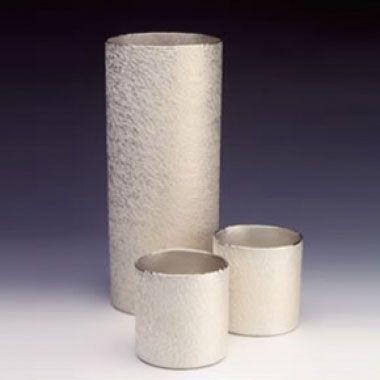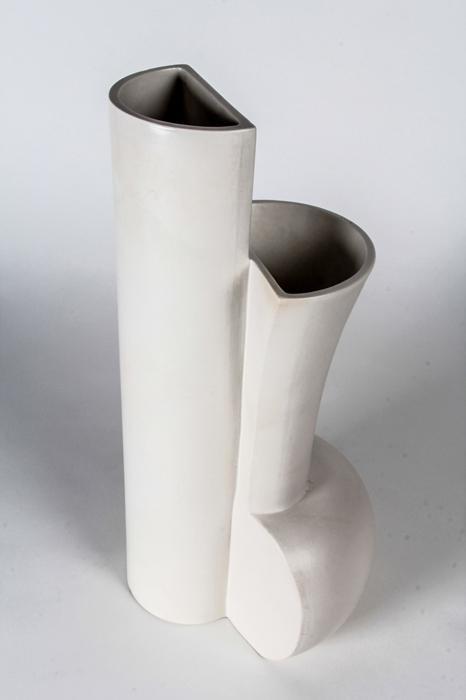The first image is the image on the left, the second image is the image on the right. Examine the images to the left and right. Is the description "There are four pieces of pottery with four holes." accurate? Answer yes or no. No. The first image is the image on the left, the second image is the image on the right. Given the left and right images, does the statement "There are four white vases standing in groups of two." hold true? Answer yes or no. No. 